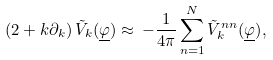<formula> <loc_0><loc_0><loc_500><loc_500>\left ( 2 + k \partial _ { k } \right ) { \tilde { V } _ { k } ( { \underline { \varphi } } ) } \approx \, - \frac { 1 } { 4 \pi } \sum _ { n = 1 } ^ { N } { \tilde { V } ^ { n n } _ { k } ( { \underline { \varphi } } ) } ,</formula> 